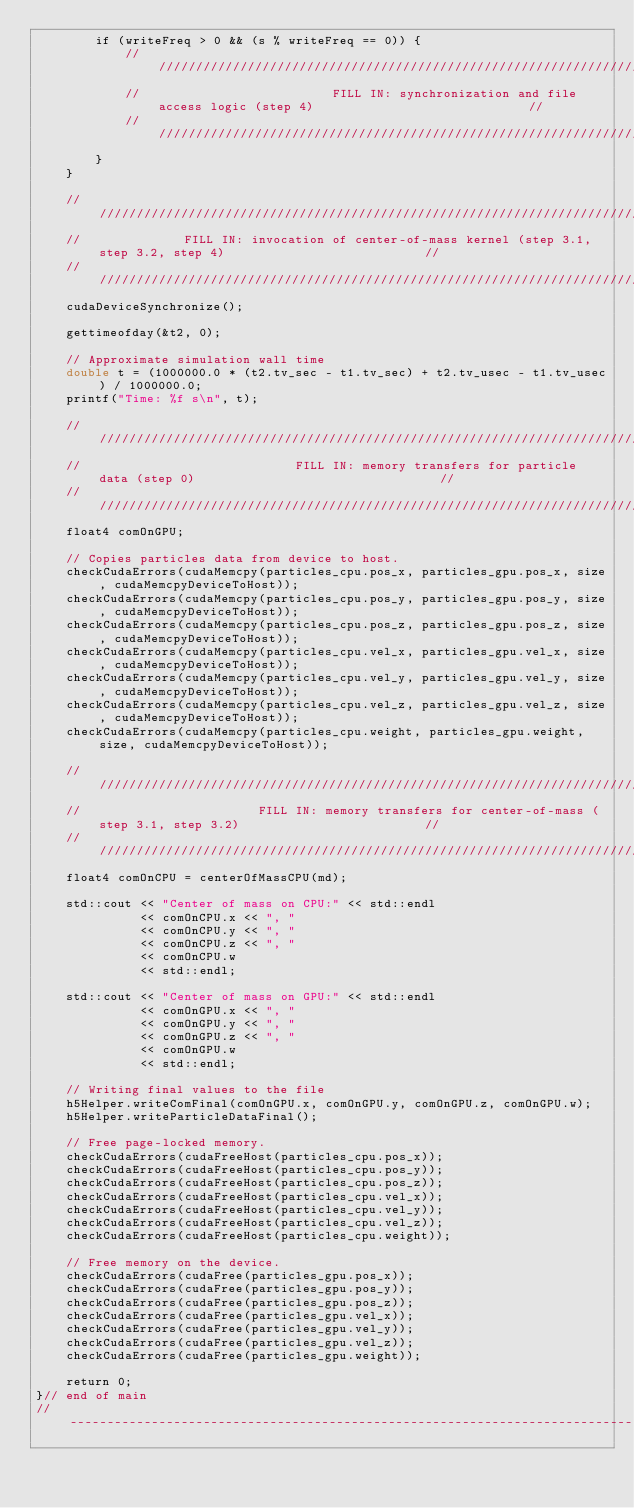<code> <loc_0><loc_0><loc_500><loc_500><_Cuda_>        if (writeFreq > 0 && (s % writeFreq == 0)) {
            //////////////////////////////////////////////////////////////////////////////////////////////////////////////////
            //                          FILL IN: synchronization and file access logic (step 4)                             //
            //////////////////////////////////////////////////////////////////////////////////////////////////////////////////
        }
    }

    //////////////////////////////////////////////////////////////////////////////////////////////////////////////////////
    //              FILL IN: invocation of center-of-mass kernel (step 3.1, step 3.2, step 4)                           //
    //////////////////////////////////////////////////////////////////////////////////////////////////////////////////////
    cudaDeviceSynchronize();

    gettimeofday(&t2, 0);

    // Approximate simulation wall time
    double t = (1000000.0 * (t2.tv_sec - t1.tv_sec) + t2.tv_usec - t1.tv_usec) / 1000000.0;
    printf("Time: %f s\n", t);

    //////////////////////////////////////////////////////////////////////////////////////////////////////////////////////
    //                             FILL IN: memory transfers for particle data (step 0)                                 //
    //////////////////////////////////////////////////////////////////////////////////////////////////////////////////////
    float4 comOnGPU;

    // Copies particles data from device to host.
    checkCudaErrors(cudaMemcpy(particles_cpu.pos_x, particles_gpu.pos_x, size, cudaMemcpyDeviceToHost));
    checkCudaErrors(cudaMemcpy(particles_cpu.pos_y, particles_gpu.pos_y, size, cudaMemcpyDeviceToHost));
    checkCudaErrors(cudaMemcpy(particles_cpu.pos_z, particles_gpu.pos_z, size, cudaMemcpyDeviceToHost));
    checkCudaErrors(cudaMemcpy(particles_cpu.vel_x, particles_gpu.vel_x, size, cudaMemcpyDeviceToHost));
    checkCudaErrors(cudaMemcpy(particles_cpu.vel_y, particles_gpu.vel_y, size, cudaMemcpyDeviceToHost));
    checkCudaErrors(cudaMemcpy(particles_cpu.vel_z, particles_gpu.vel_z, size, cudaMemcpyDeviceToHost));
    checkCudaErrors(cudaMemcpy(particles_cpu.weight, particles_gpu.weight, size, cudaMemcpyDeviceToHost));

    //////////////////////////////////////////////////////////////////////////////////////////////////////////////////////
    //                        FILL IN: memory transfers for center-of-mass (step 3.1, step 3.2)                         //
    //////////////////////////////////////////////////////////////////////////////////////////////////////////////////////
    float4 comOnCPU = centerOfMassCPU(md);

    std::cout << "Center of mass on CPU:" << std::endl
              << comOnCPU.x << ", "
              << comOnCPU.y << ", "
              << comOnCPU.z << ", "
              << comOnCPU.w
              << std::endl;

    std::cout << "Center of mass on GPU:" << std::endl
              << comOnGPU.x << ", "
              << comOnGPU.y << ", "
              << comOnGPU.z << ", "
              << comOnGPU.w
              << std::endl;

    // Writing final values to the file
    h5Helper.writeComFinal(comOnGPU.x, comOnGPU.y, comOnGPU.z, comOnGPU.w);
    h5Helper.writeParticleDataFinal();

    // Free page-locked memory.
    checkCudaErrors(cudaFreeHost(particles_cpu.pos_x));
    checkCudaErrors(cudaFreeHost(particles_cpu.pos_y));
    checkCudaErrors(cudaFreeHost(particles_cpu.pos_z));
    checkCudaErrors(cudaFreeHost(particles_cpu.vel_x));
    checkCudaErrors(cudaFreeHost(particles_cpu.vel_y));
    checkCudaErrors(cudaFreeHost(particles_cpu.vel_z));
    checkCudaErrors(cudaFreeHost(particles_cpu.weight));

    // Free memory on the device.
    checkCudaErrors(cudaFree(particles_gpu.pos_x));
    checkCudaErrors(cudaFree(particles_gpu.pos_y));
    checkCudaErrors(cudaFree(particles_gpu.pos_z));
    checkCudaErrors(cudaFree(particles_gpu.vel_x));
    checkCudaErrors(cudaFree(particles_gpu.vel_y));
    checkCudaErrors(cudaFree(particles_gpu.vel_z));
    checkCudaErrors(cudaFree(particles_gpu.weight));

    return 0;
}// end of main
//----------------------------------------------------------------------------------------------------------------------
</code> 